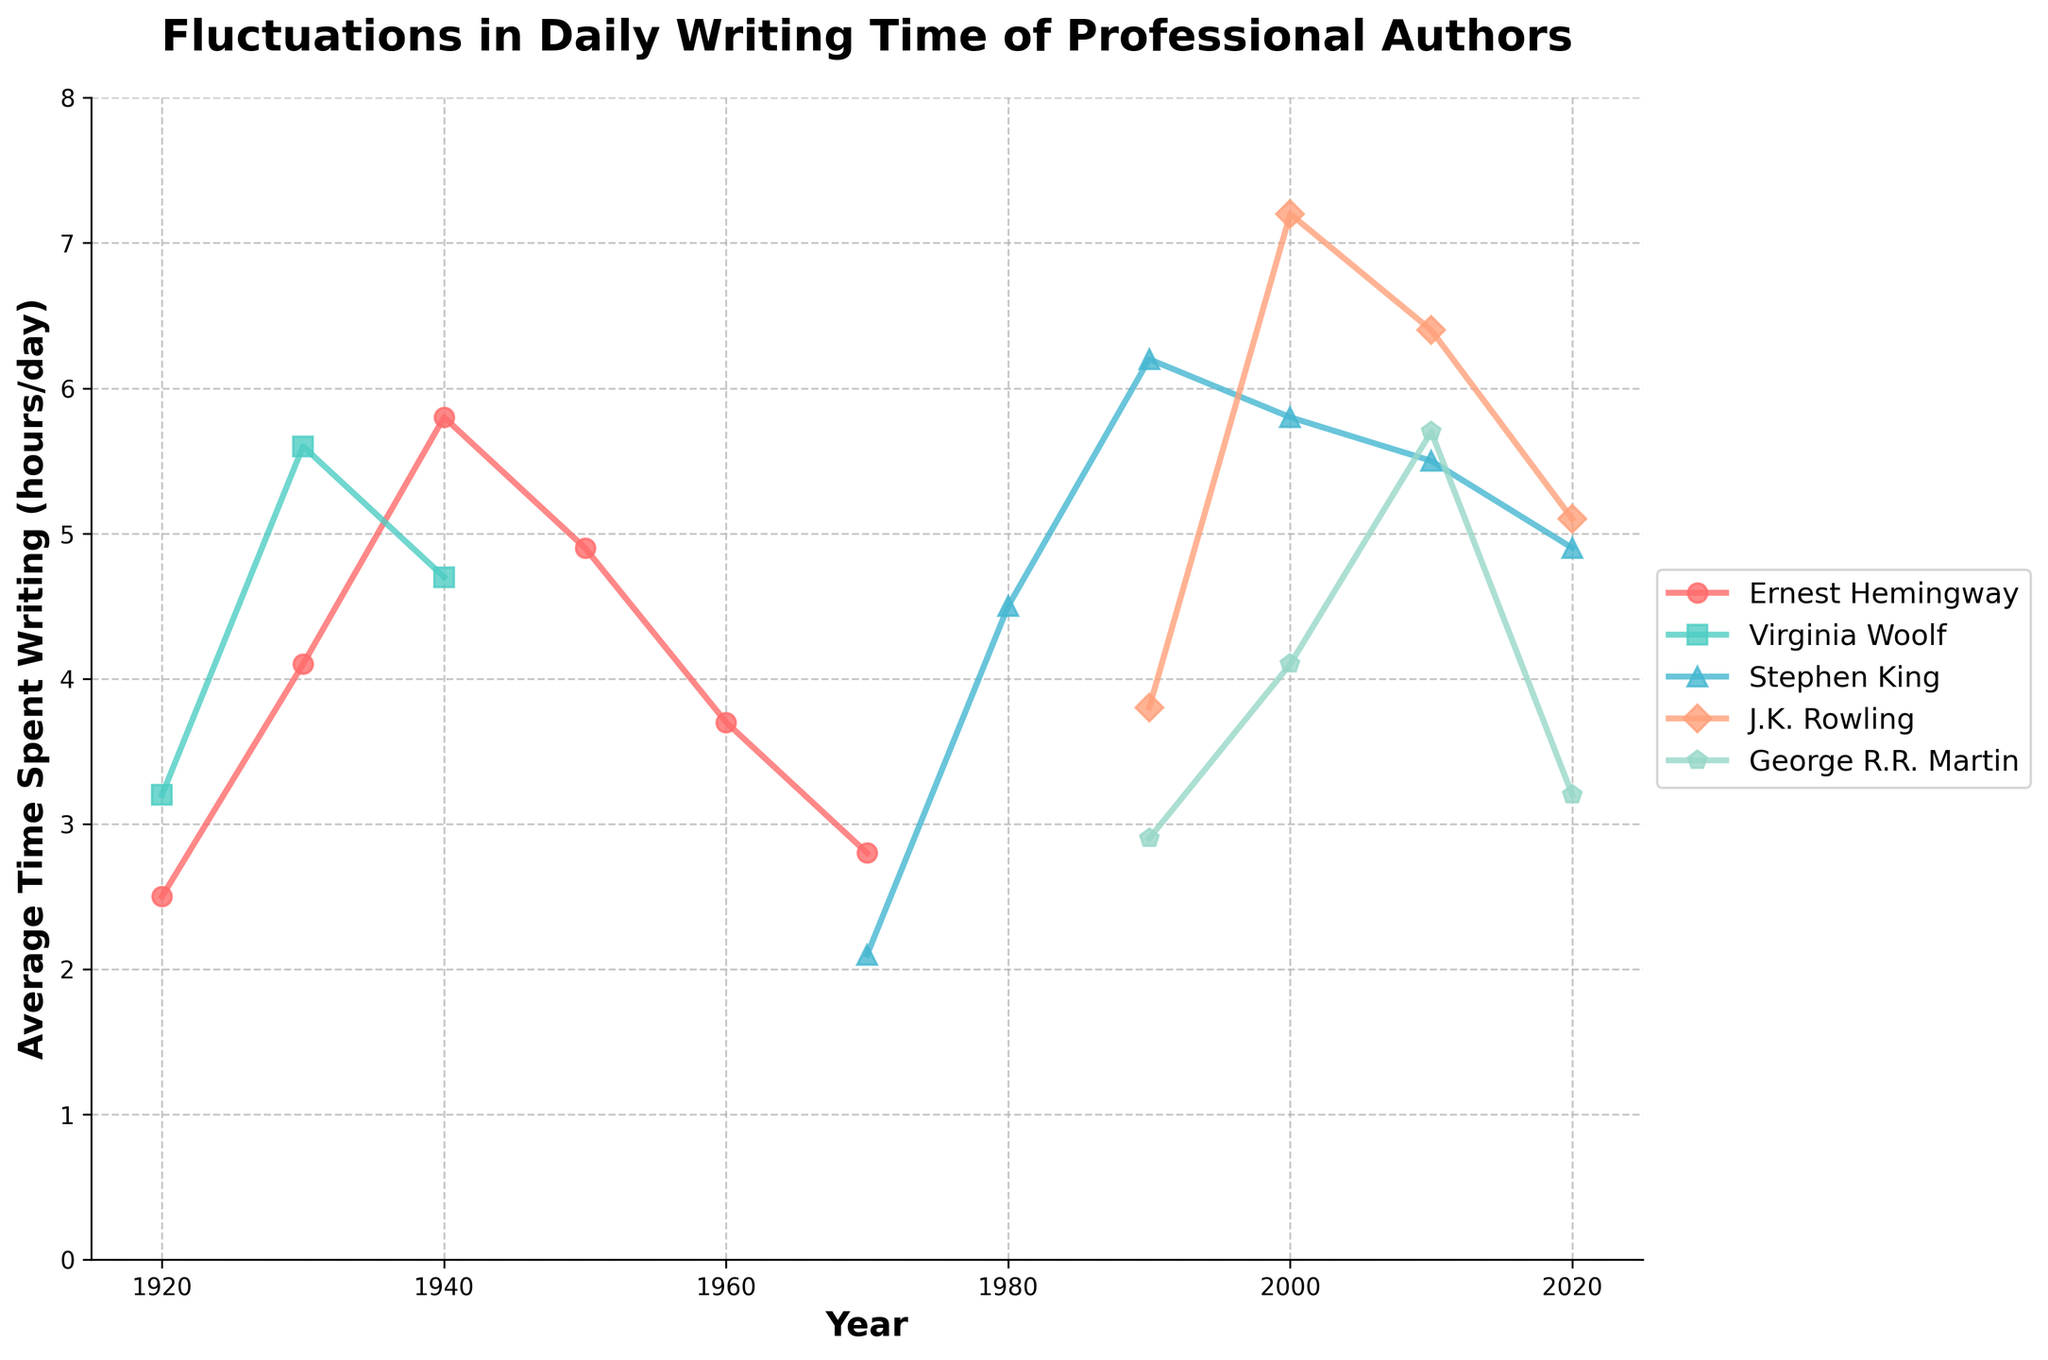How many years did Virginia Woolf spend the most time writing per day? Looking at the figure, we see that Virginia Woolf's peak writing time is around 1930, where the data point is at its highest compared to other years.
Answer: 1930 Who spent more time writing per day on average in the 2000s, J.K. Rowling or George R.R. Martin? Observe the data points for J.K. Rowling and George R.R. Martin in the 2000s. J.K. Rowling's values are higher, with an average of around 6.15 hours compared to George R.R. Martin's 4.33 hours.
Answer: J.K. Rowling What is the difference between Ernest Hemingway's highest and lowest writing times? The highest value for Ernest Hemingway is 5.8 in 1940 and the lowest is 2.5 in 1920. The difference is 5.8 - 2.5.
Answer: 3.3 During which decade did Stephen King experience the greatest increase in his writing time? Compare Stephen King's data points over the decades. The biggest jump is from 1990 (6.2) to 2000 (5.8), which spans the least time between these points - hence, showing the greatest increase.
Answer: 1990s If you average the daily writing times of all authors in 2010, what do you get? Add up the writing times in 2010 for all authors (5.5 from Stephen King, 6.4 from J.K. Rowling, and 5.7 from George R.R. Martin) and divide by the number of authors (3). (5.5 + 6.4 + 5.7) / 3 = 5.87
Answer: 5.87 By how much did J.K. Rowling's daily writing time decrease from 2000 to 2020? Looking at the figure, J.K. Rowling's daily writing time went from 7.2 in 2000 to 5.1 in 2020. The decrease is 7.2 - 5.1.
Answer: 2.1 Which author has the most consistent writing time over the recorded years? Stephen King shows the least fluctuation in his writing times across the decades, particularly remaining fairly stable between 1990 and 2020.
Answer: Stephen King What is the overall trend in Ernest Hemingway's writing time throughout his career? From the chart, it appears that Hemingway's writing time increases from 1920 to 1940 and then decreases towards 1970.
Answer: Increasing then decreasing What year did George R.R. Martin write the most per day? Look at the figure's data points for George R.R. Martin. The highest point is in 2010, with 5.7 hours.
Answer: 2010 